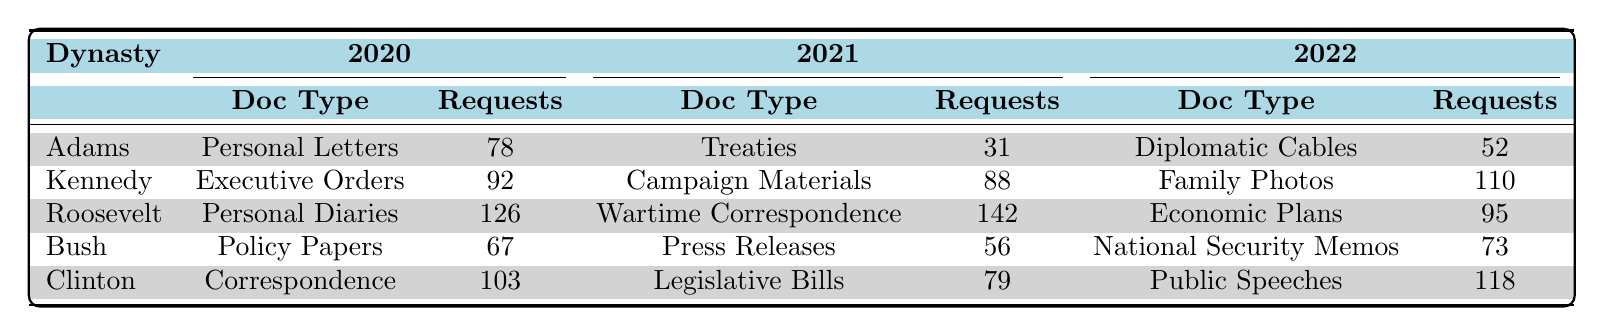What is the total number of document requests for the Adams dynasty in 2021? From the table, the requests for the Adams dynasty in 2021 are 31 for Treaties. Thus, the total is 31.
Answer: 31 Which document type related to the Kennedy dynasty had the highest requests in 2022? From the Kennedy dynasty's entries in 2022, Family Photos had 110 requests, which is higher than the other document types listed.
Answer: Family Photos How many requests did the Roosevelt dynasty receive for document types in total across all three years? Summing up the requests for the Roosevelt dynasty across the years: 126 (2020) + 142 (2021) + 95 (2022) = 363.
Answer: 363 Is the number of requests for Public Speeches by the Clinton dynasty greater than the requests for Campaign Materials by the Kennedy dynasty? The Clinton dynasty received 118 requests for Public Speeches while the Kennedy dynasty had 88 requests for Campaign Materials. Since 118 is greater than 88, the answer is yes.
Answer: Yes What is the average number of document requests for the Bush dynasty over the three years? The requests for the Bush dynasty are: 67 (2020), 56 (2021), and 73 (2022). To find the average, sum these requests (67 + 56 + 73 = 196) and divide by the number of years (3), resulting in an average of 196 / 3 = 65.33.
Answer: 65.33 Which dynasty had the least number of document requests in 2021? The requests for each dynasty in 2021 were: Adams (31), Kennedy (88), Roosevelt (142), Bush (56), and Clinton (79). The least is 31 for the Adams dynasty.
Answer: Adams How many more requests did the Roosevelt dynasty have in 2021 compared to the Bush dynasty? In 2021, the Roosevelt dynasty had 142 requests, while the Bush dynasty had 56 requests. The difference is 142 - 56 = 86.
Answer: 86 Did the total requests for the Clinton dynasty in 2020 exceed 100? In 2020, the Clinton dynasty had 103 requests for Correspondence. Since 103 is greater than 100, the answer is yes.
Answer: Yes What is the total number of requests for document types from 2020 that were requested by Historians? From 2020, the only request by a Historian is for Personal Letters under the Adams dynasty, with 78 requests. Thus the total is 78.
Answer: 78 